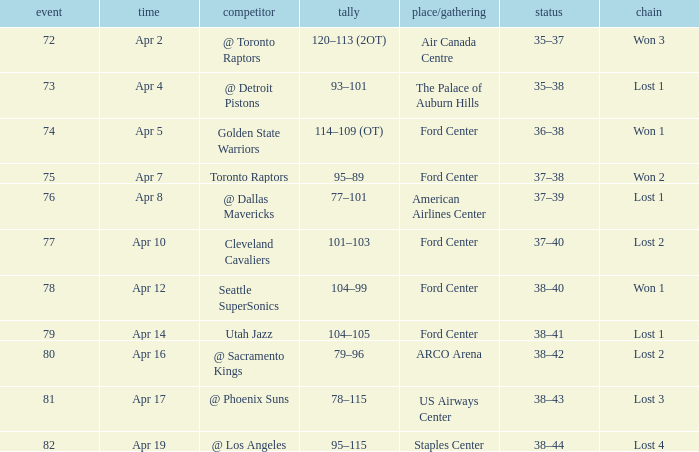What was the record for less than 78 games and a score of 114–109 (ot)? 36–38. 